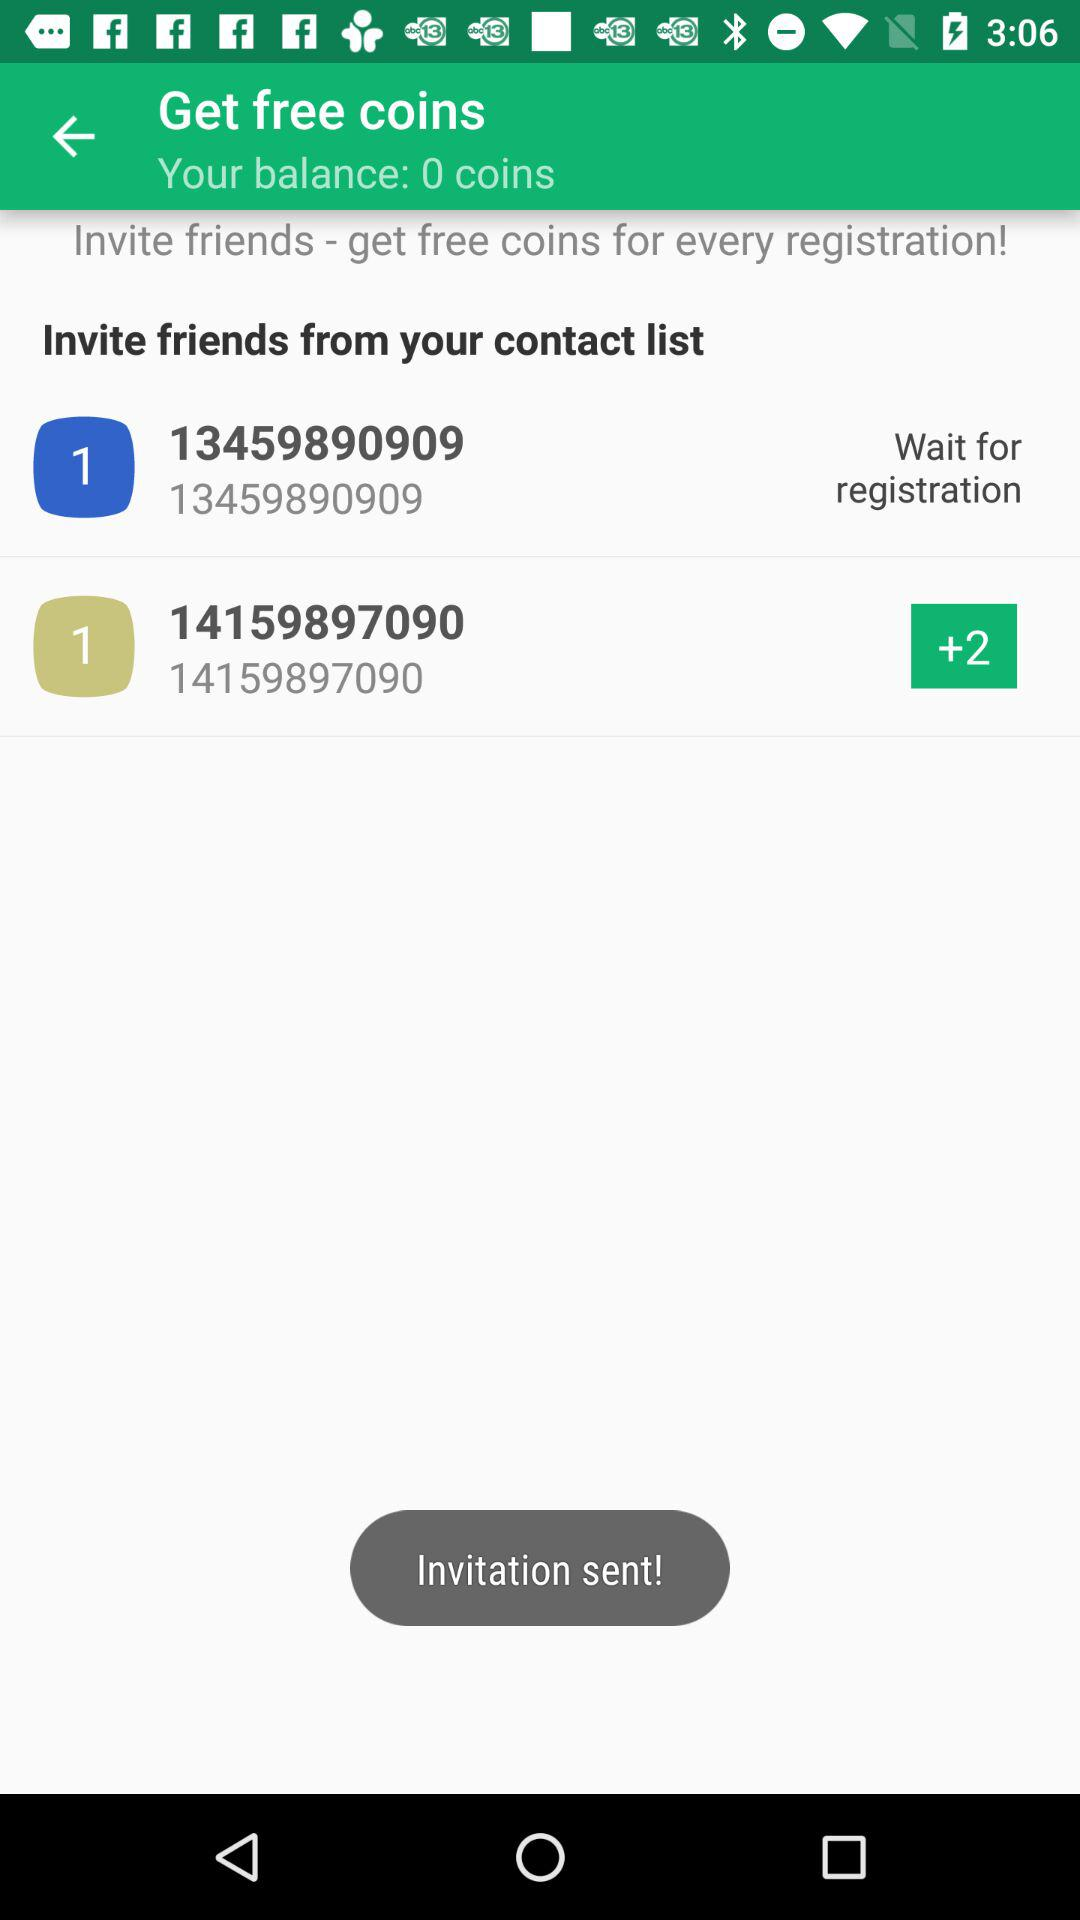How many friends have you invited?
Answer the question using a single word or phrase. 2 